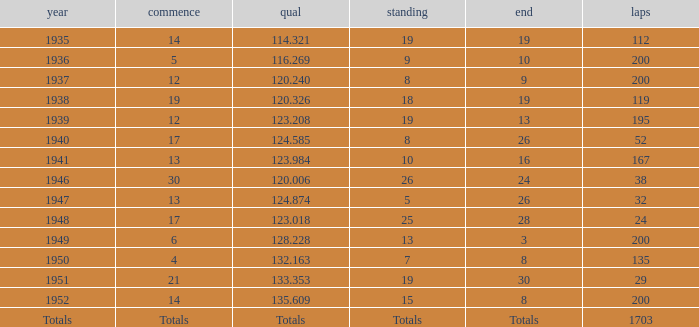In 1937, what was the finish? 9.0. 